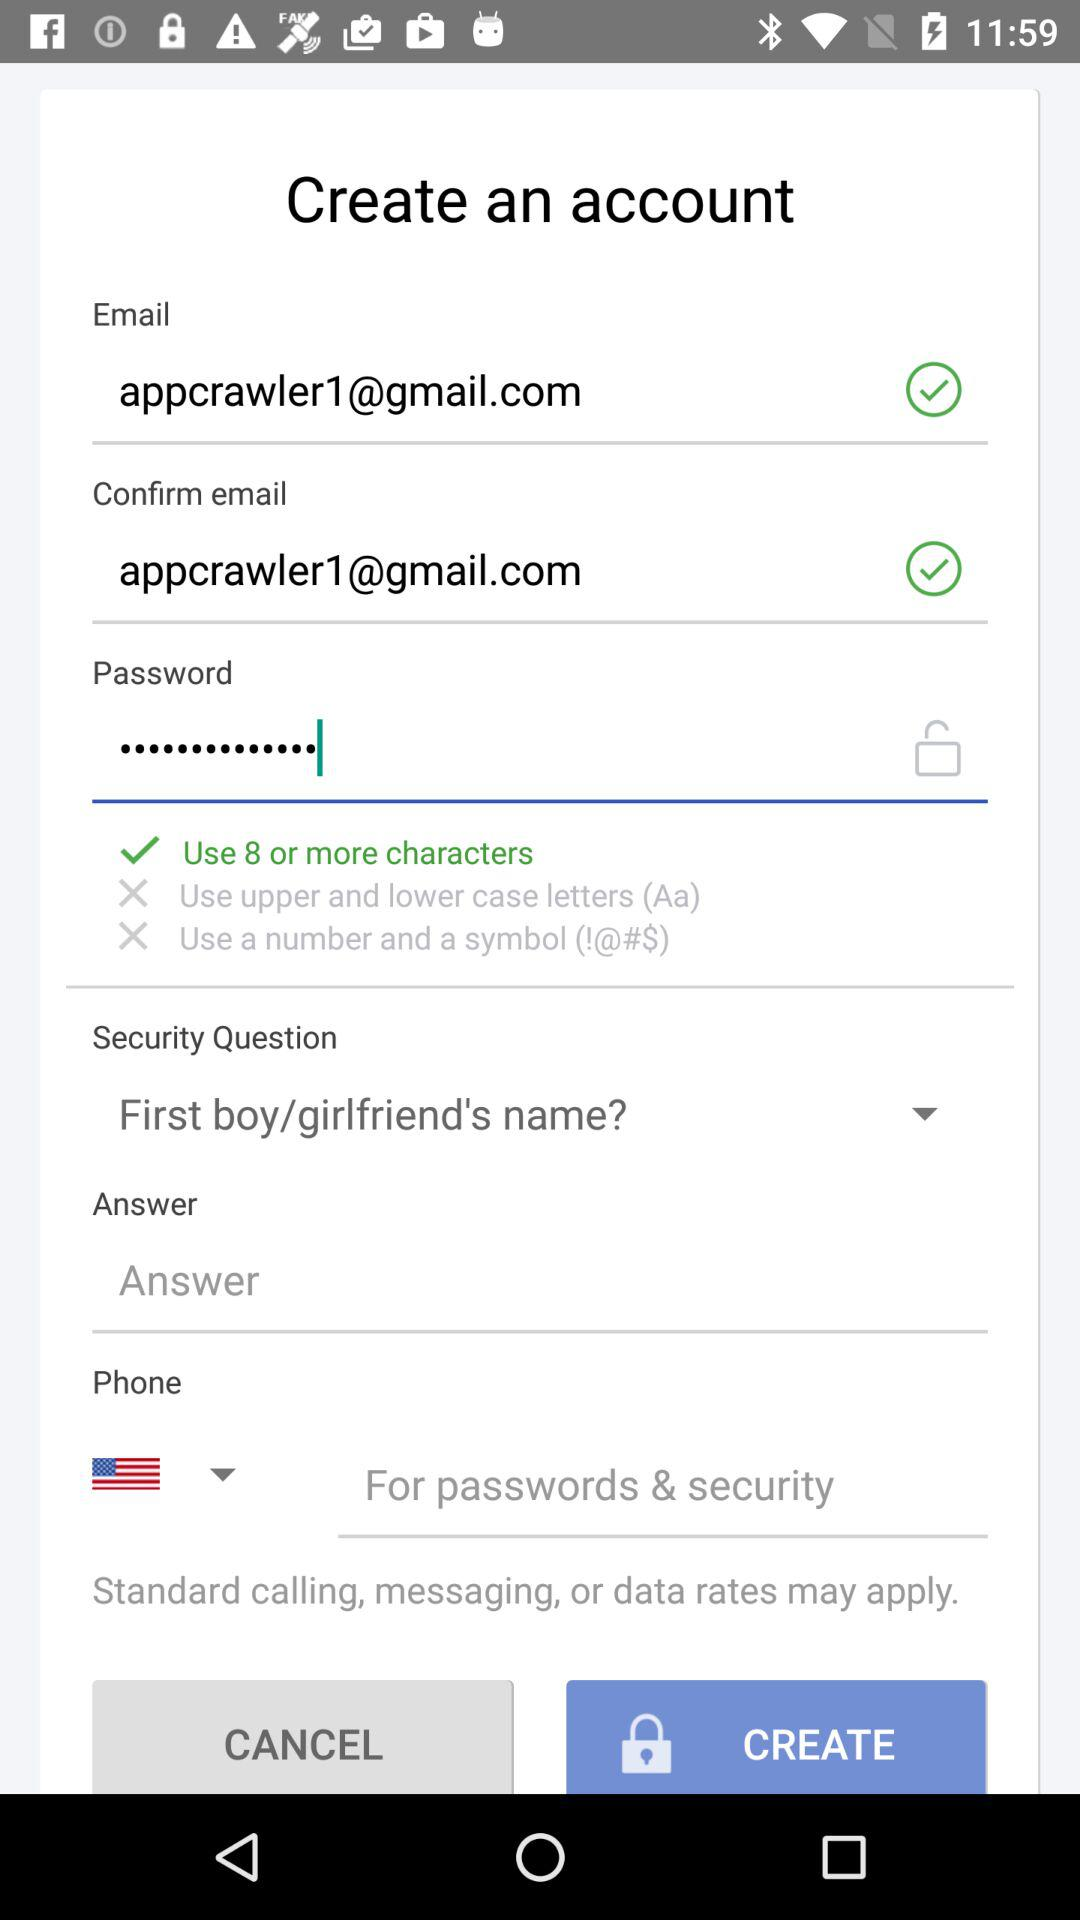What is the email address? The email address is appcrawler1@gmail.com. 